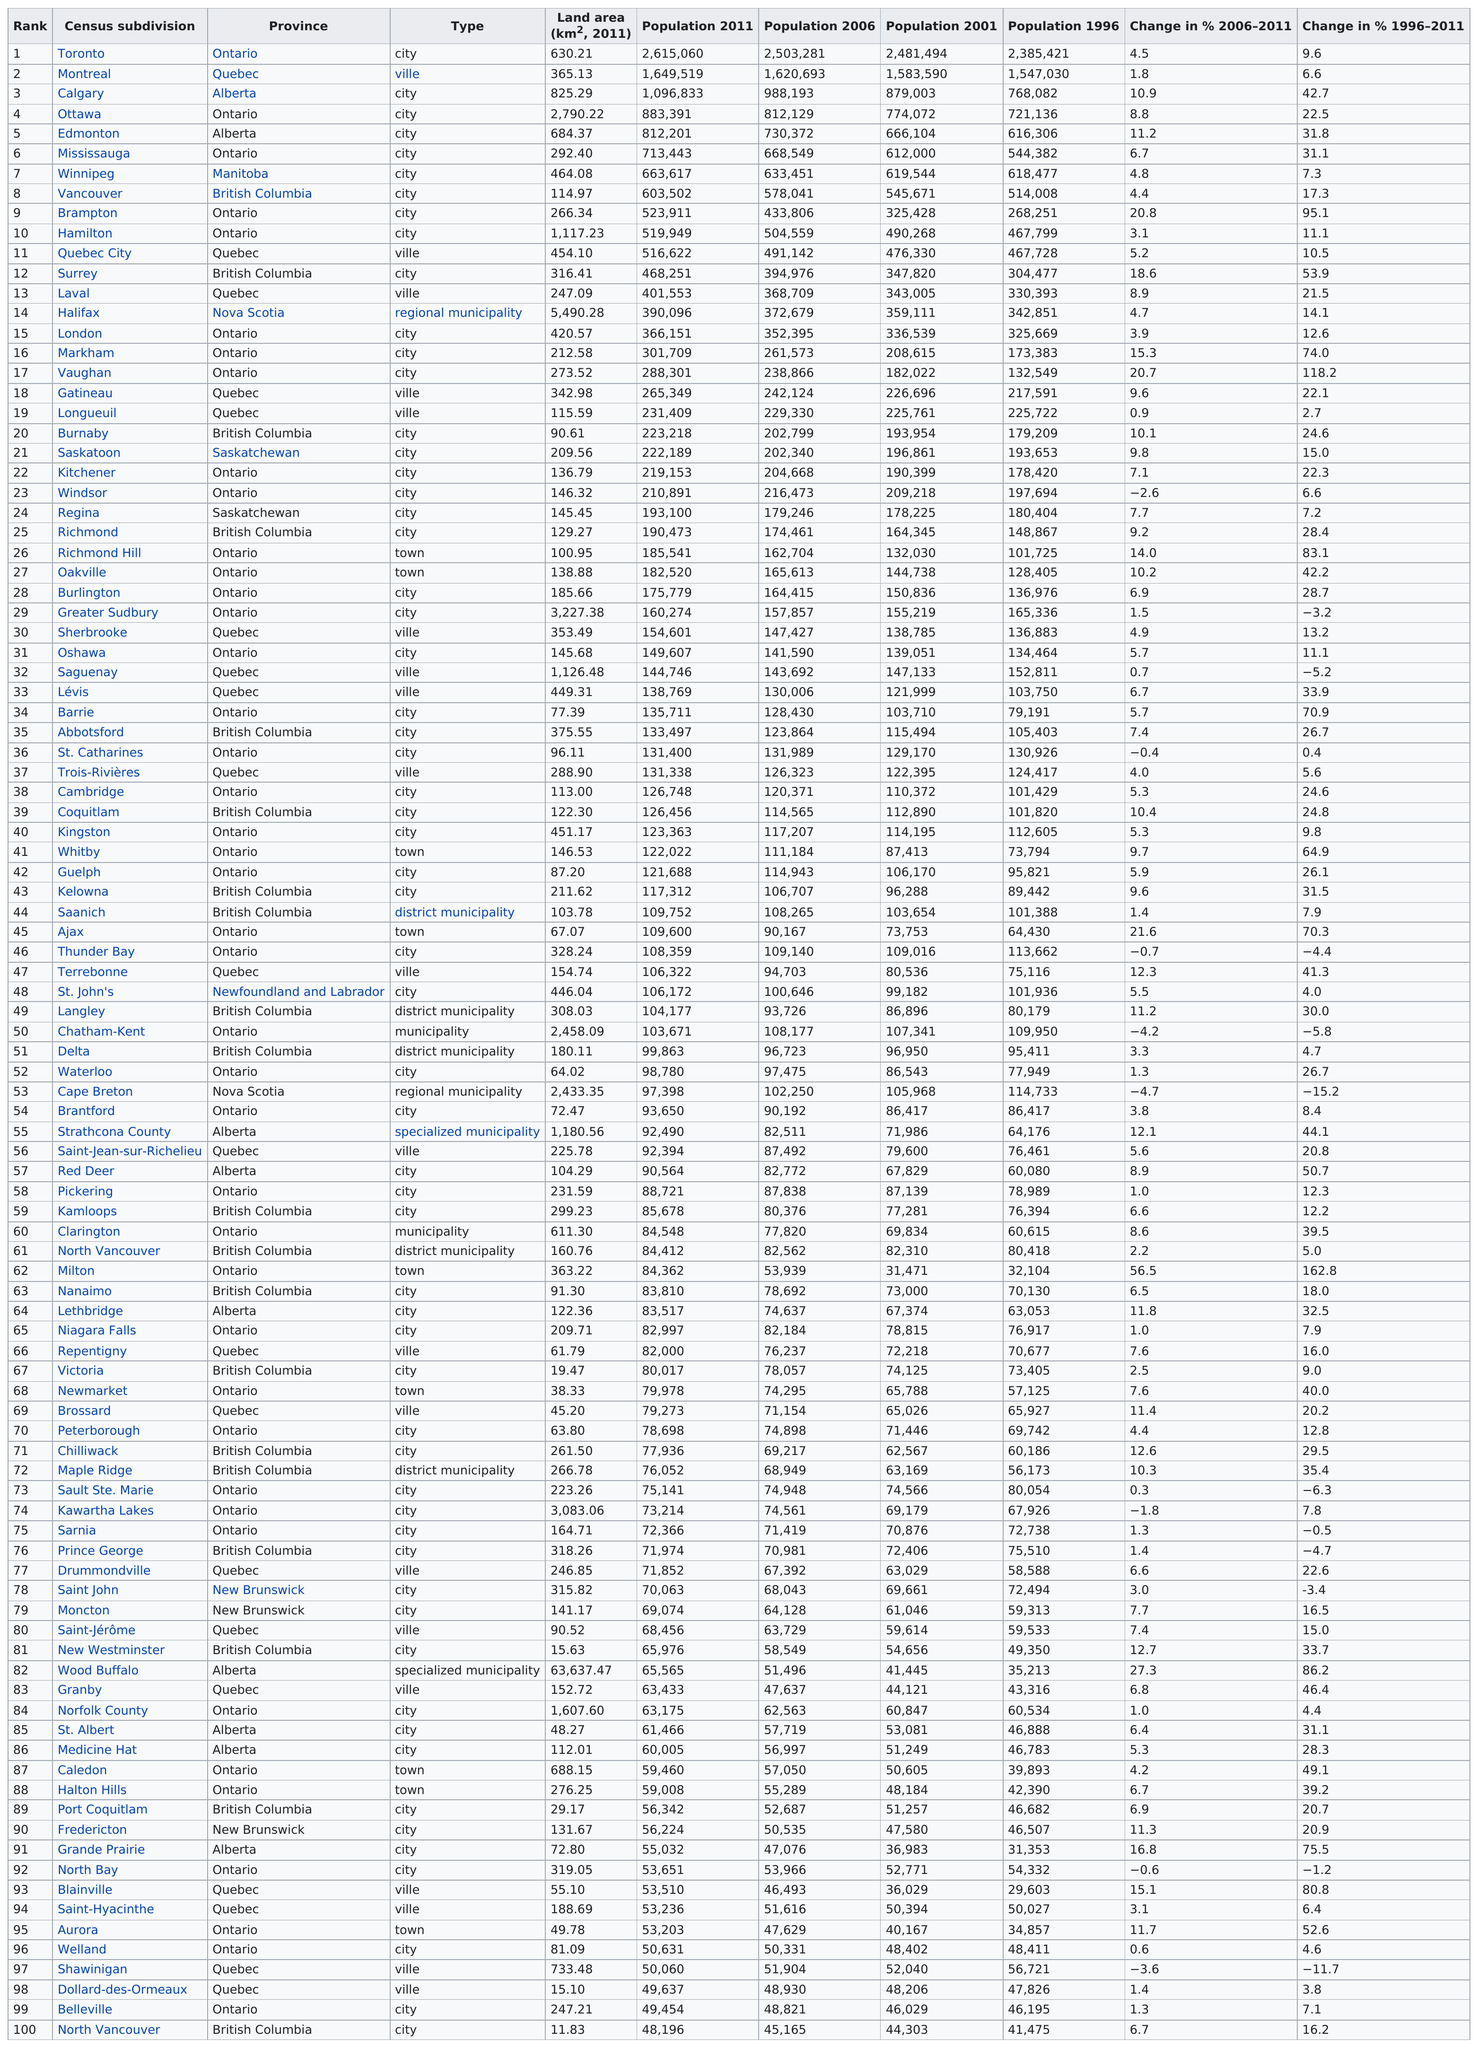Give some essential details in this illustration. Among the municipalities that experienced an increase in population from 2006 to 2011, the one with the smallest population growth was Sault Ste. Marie. According to the 2011 census, out of the 10 census subdivisions with the highest population in Canada, five were located in the province of Ontario. In Nova Scotia, only two areas have been designated as regional municipalities: Halifax and Cape Breton. Edmonton has a larger land area than Winnipeg. Ontario has the most population among the provinces on the table. 